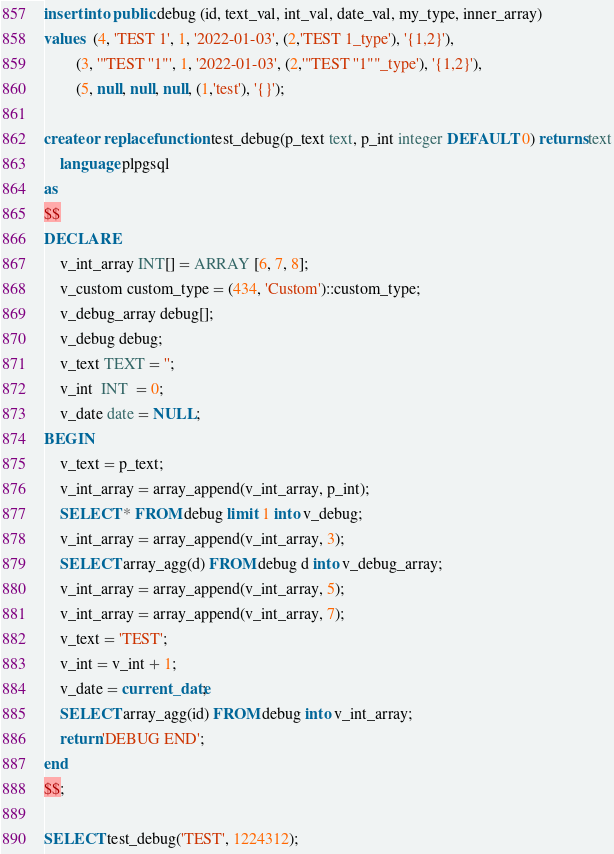Convert code to text. <code><loc_0><loc_0><loc_500><loc_500><_SQL_>insert into public.debug (id, text_val, int_val, date_val, my_type, inner_array)
values  (4, 'TEST 1', 1, '2022-01-03', (2,'TEST 1_type'), '{1,2}'),
        (3, '"TEST ''1"', 1, '2022-01-03', (2,'"TEST ''1""_type'), '{1,2}'),
        (5, null, null, null, (1,'test'), '{}');

create or replace function test_debug(p_text text, p_int integer DEFAULT 0) returns text
    language plpgsql
as
$$
DECLARE
    v_int_array INT[] = ARRAY [6, 7, 8];
    v_custom custom_type = (434, 'Custom')::custom_type;
    v_debug_array debug[];
    v_debug debug;
    v_text TEXT = '';
    v_int  INT  = 0;
    v_date date = NULL;
BEGIN
    v_text = p_text;
    v_int_array = array_append(v_int_array, p_int);
    SELECT * FROM debug limit 1 into v_debug;
    v_int_array = array_append(v_int_array, 3);
    SELECT array_agg(d) FROM debug d into v_debug_array;
    v_int_array = array_append(v_int_array, 5);
    v_int_array = array_append(v_int_array, 7);
    v_text = 'TEST';
    v_int = v_int + 1;
    v_date = current_date;
    SELECT array_agg(id) FROM debug into v_int_array;
    return 'DEBUG END';
end
$$;

SELECT test_debug('TEST', 1224312);</code> 